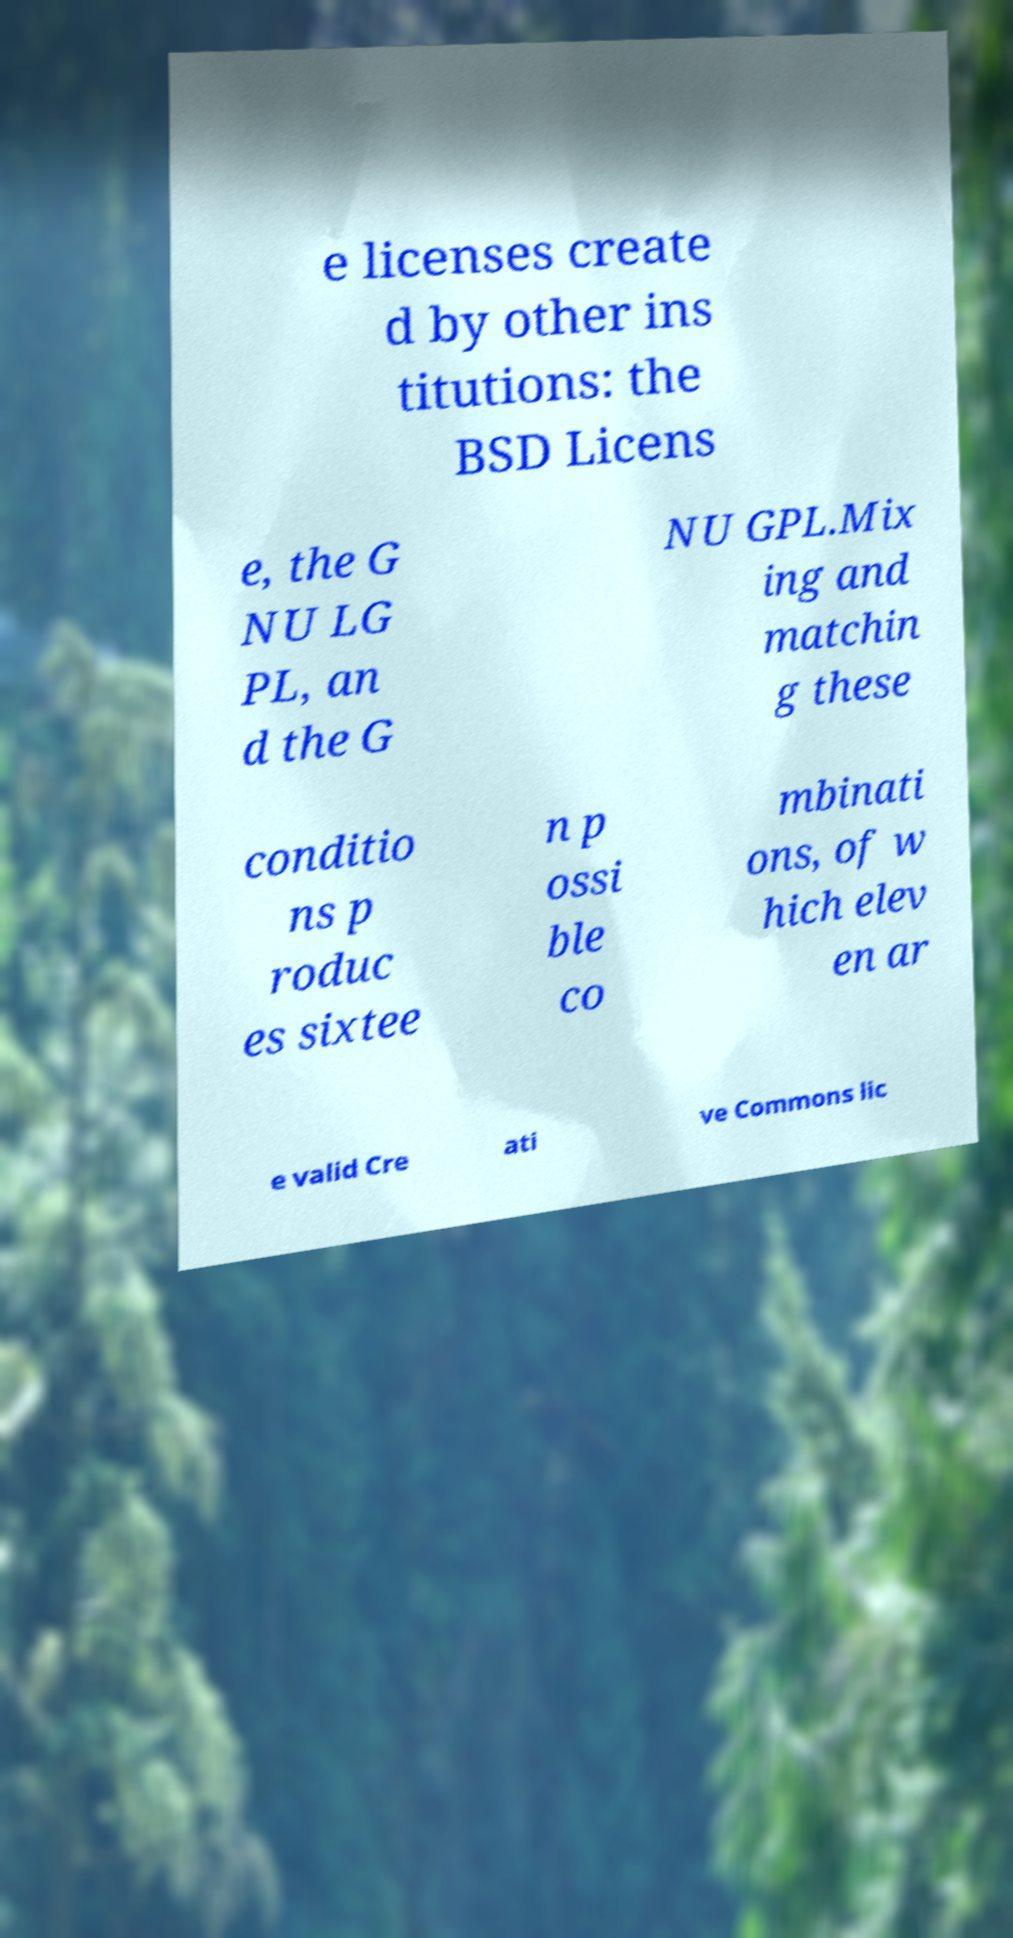Can you read and provide the text displayed in the image?This photo seems to have some interesting text. Can you extract and type it out for me? e licenses create d by other ins titutions: the BSD Licens e, the G NU LG PL, an d the G NU GPL.Mix ing and matchin g these conditio ns p roduc es sixtee n p ossi ble co mbinati ons, of w hich elev en ar e valid Cre ati ve Commons lic 